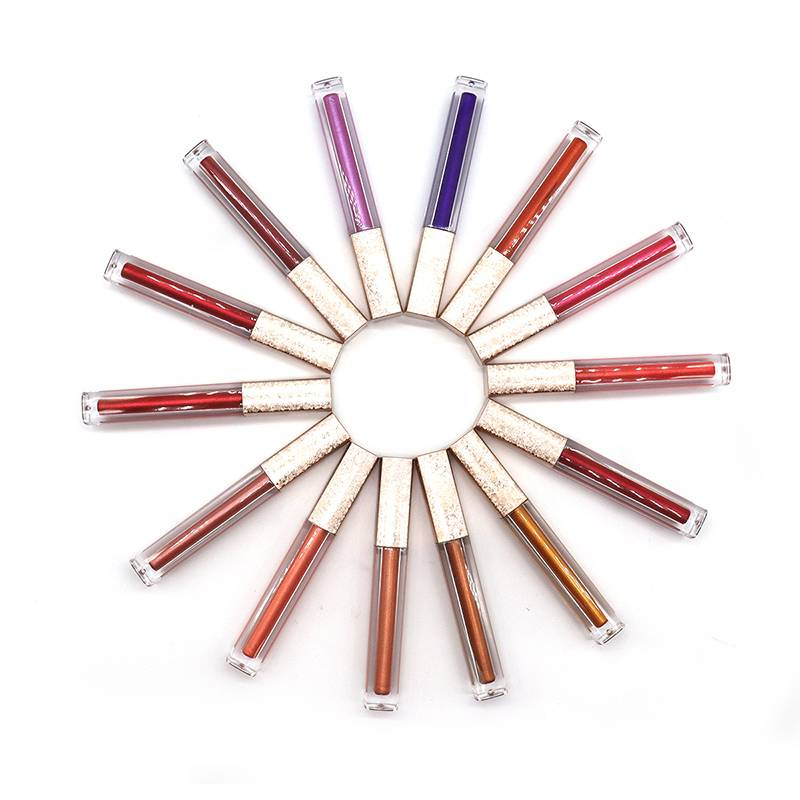Considering the arrangement and visible shades of the lip gloss tubes, which two tubes, when combined, would likely create a new shade that is not already presented among the existing tubes? Based on the visible shades in the image, combining the contents of a tube with a light pink shade and a tube with a deep purple shade could potentially create a new shade of mauve or dusty rose that is not already present among the existing tubes. This new shade would be a mix of the lightness of the pink with the depth of the purple, resulting in a color that appears to be different from the ones displayed. 